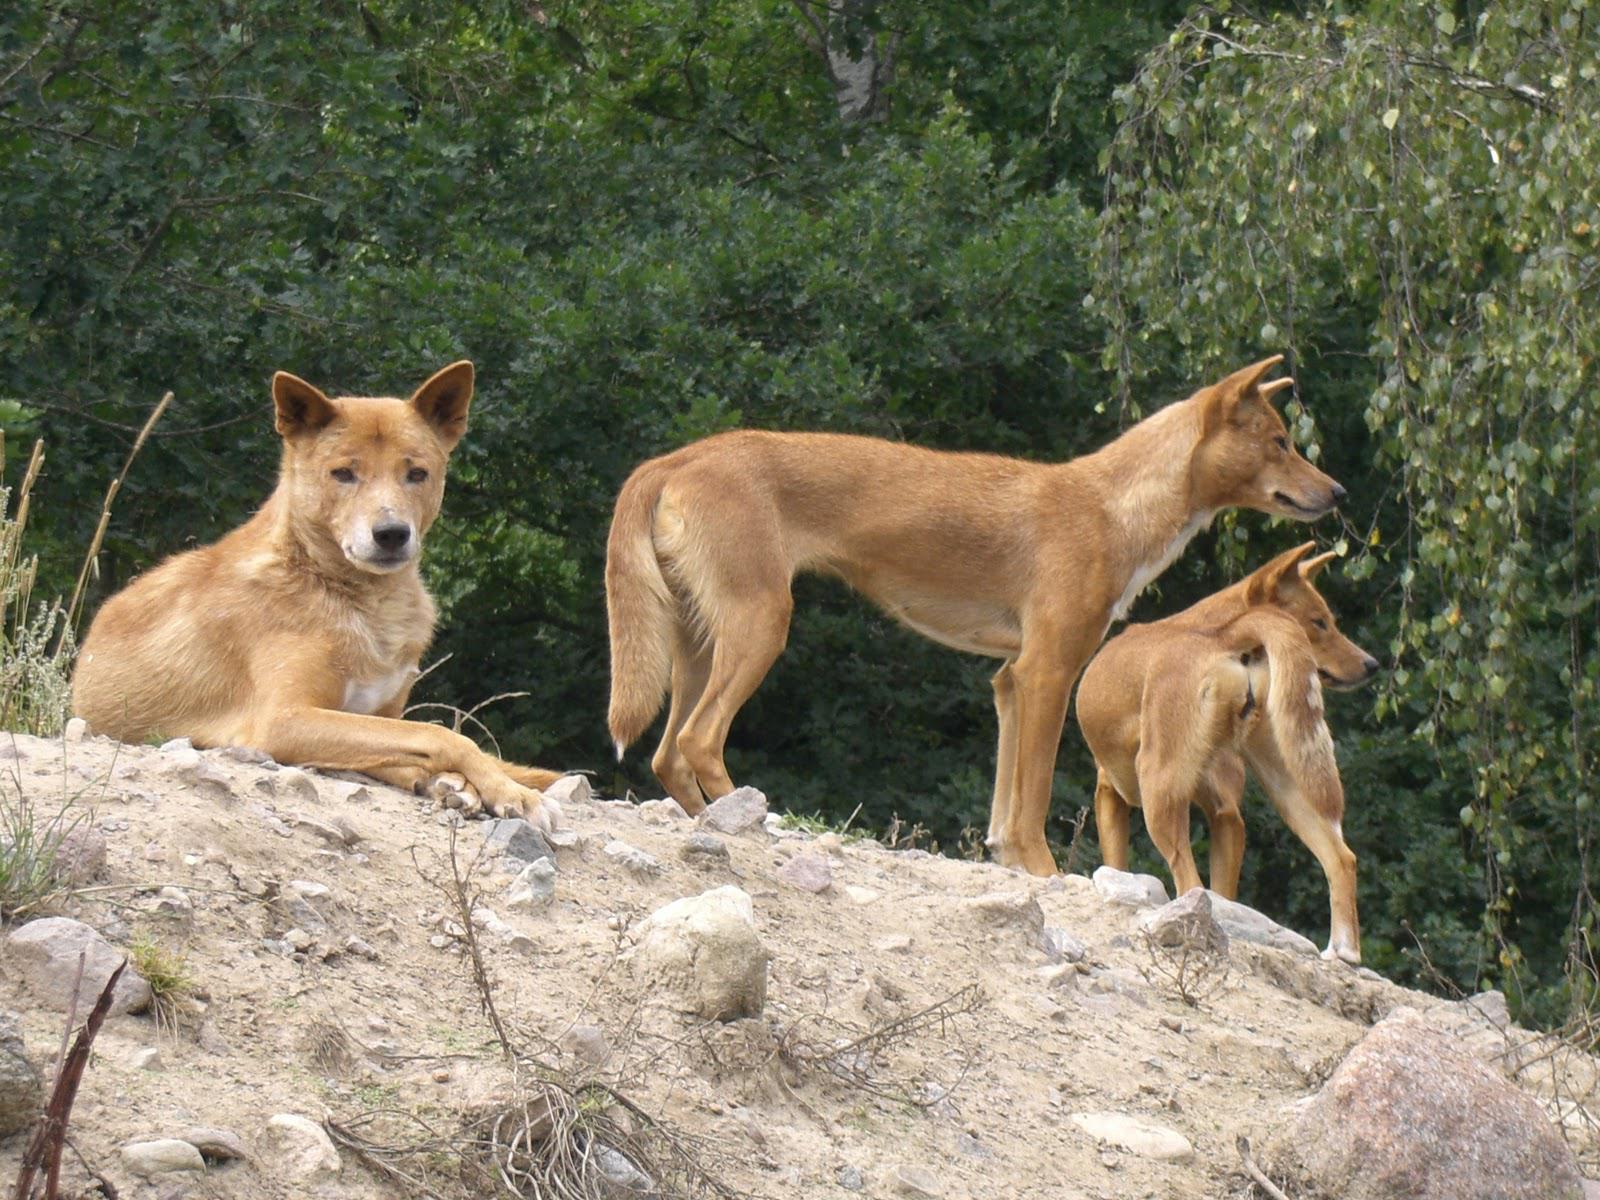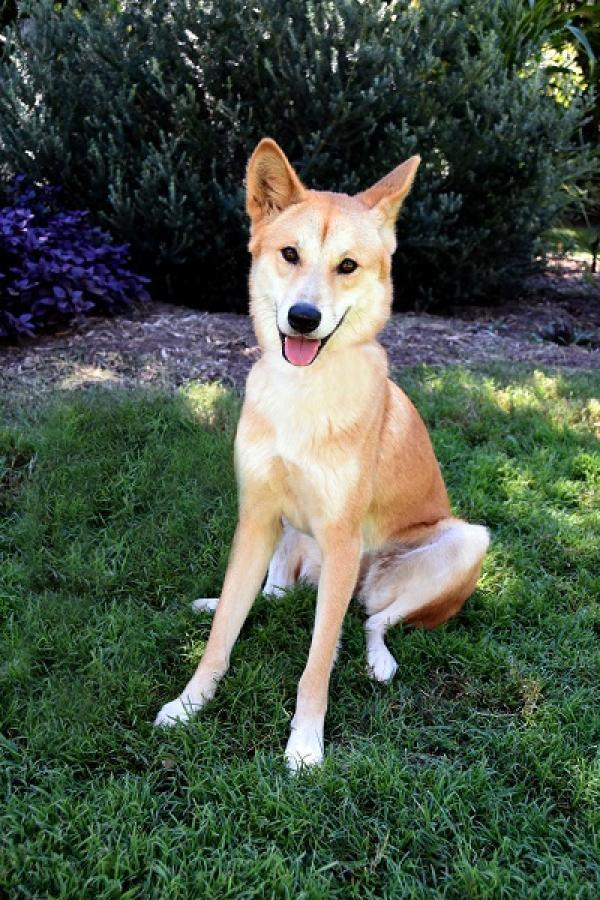The first image is the image on the left, the second image is the image on the right. Given the left and right images, does the statement "An image contains only one dog, which is standing on a rock gazing rightward." hold true? Answer yes or no. No. The first image is the image on the left, the second image is the image on the right. Assess this claim about the two images: "There are no more than 3 dogs in total.". Correct or not? Answer yes or no. No. 